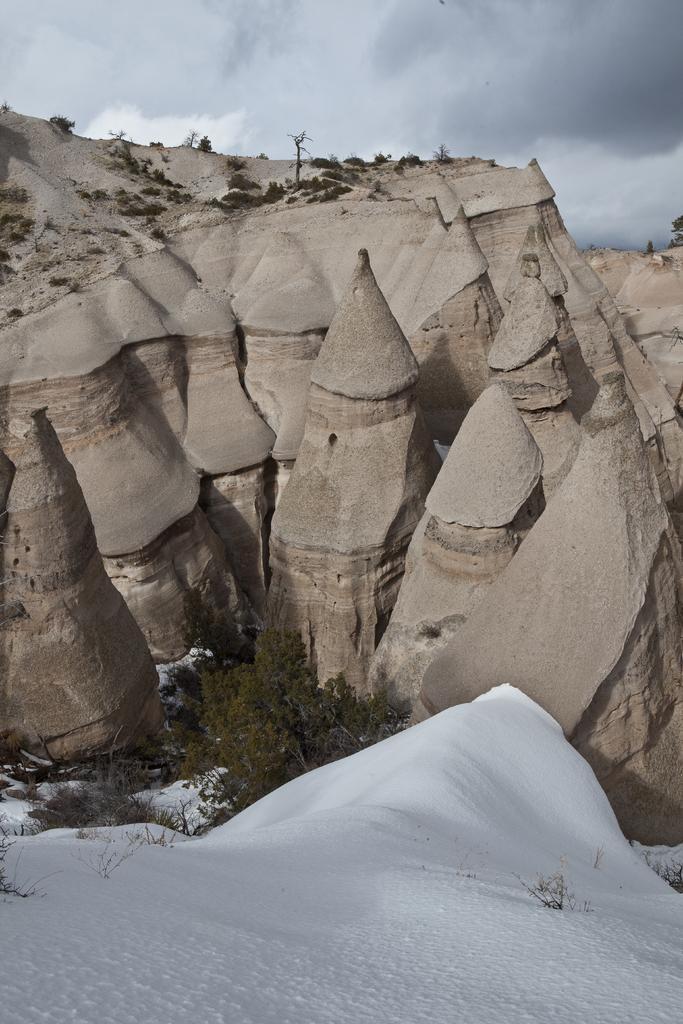Could you give a brief overview of what you see in this image? In this picture we can see snow, trees, rocks and a cloudy sky. 